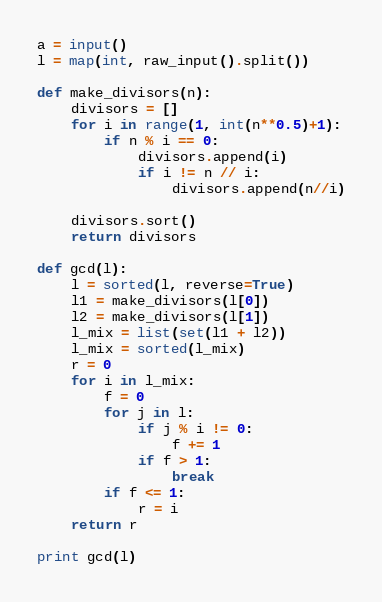Convert code to text. <code><loc_0><loc_0><loc_500><loc_500><_Python_>a = input()
l = map(int, raw_input().split())

def make_divisors(n):
    divisors = []
    for i in range(1, int(n**0.5)+1):
        if n % i == 0:
            divisors.append(i)
            if i != n // i:
                divisors.append(n//i)

    divisors.sort()
    return divisors

def gcd(l):
	l = sorted(l, reverse=True)
	l1 = make_divisors(l[0])
	l2 = make_divisors(l[1])
	l_mix = list(set(l1 + l2))
	l_mix = sorted(l_mix)
	r = 0
	for i in l_mix:
		f = 0
		for j in l:
			if j % i != 0:
				f += 1
			if f > 1:
				break
		if f <= 1:
			r = i
	return r 

print gcd(l)</code> 